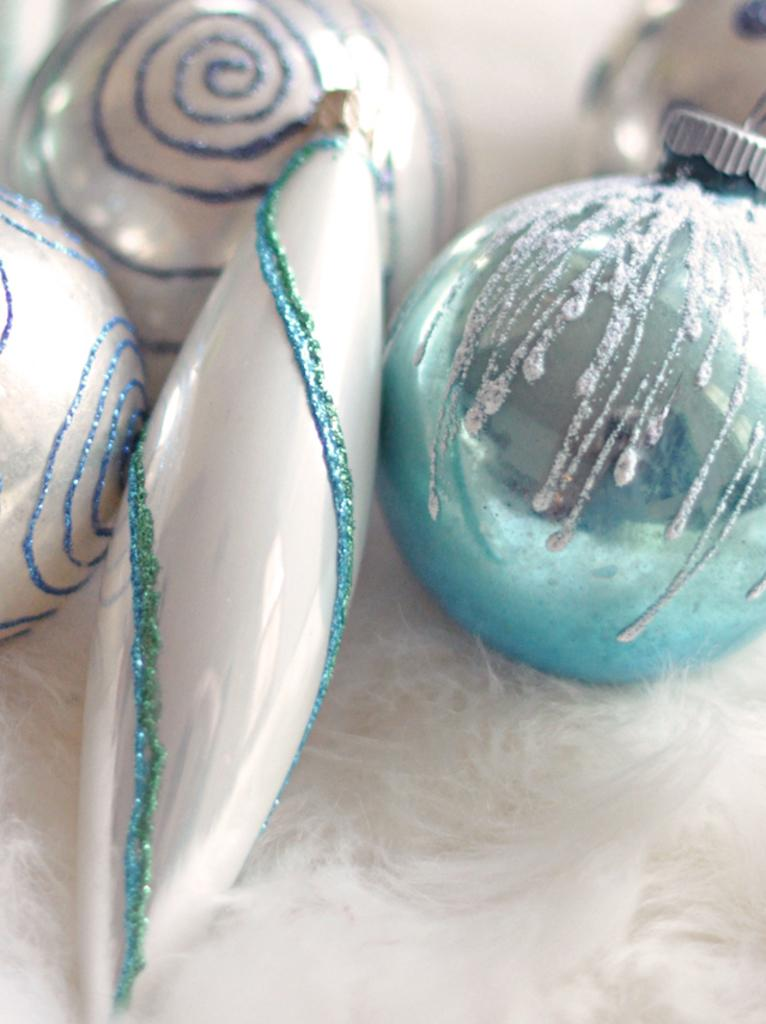What types of objects can be seen in the image? There are decorative items in the image. Can you describe the colors of the decorative items? The decorative items are white and blue in color. What is the color of the background in the image? The background of the image is white. How many ants can be seen crawling on the decorative items during the rainstorm in the image? There are no ants or rainstorm present in the image; it only features decorative items with white and blue colors against a white background. 